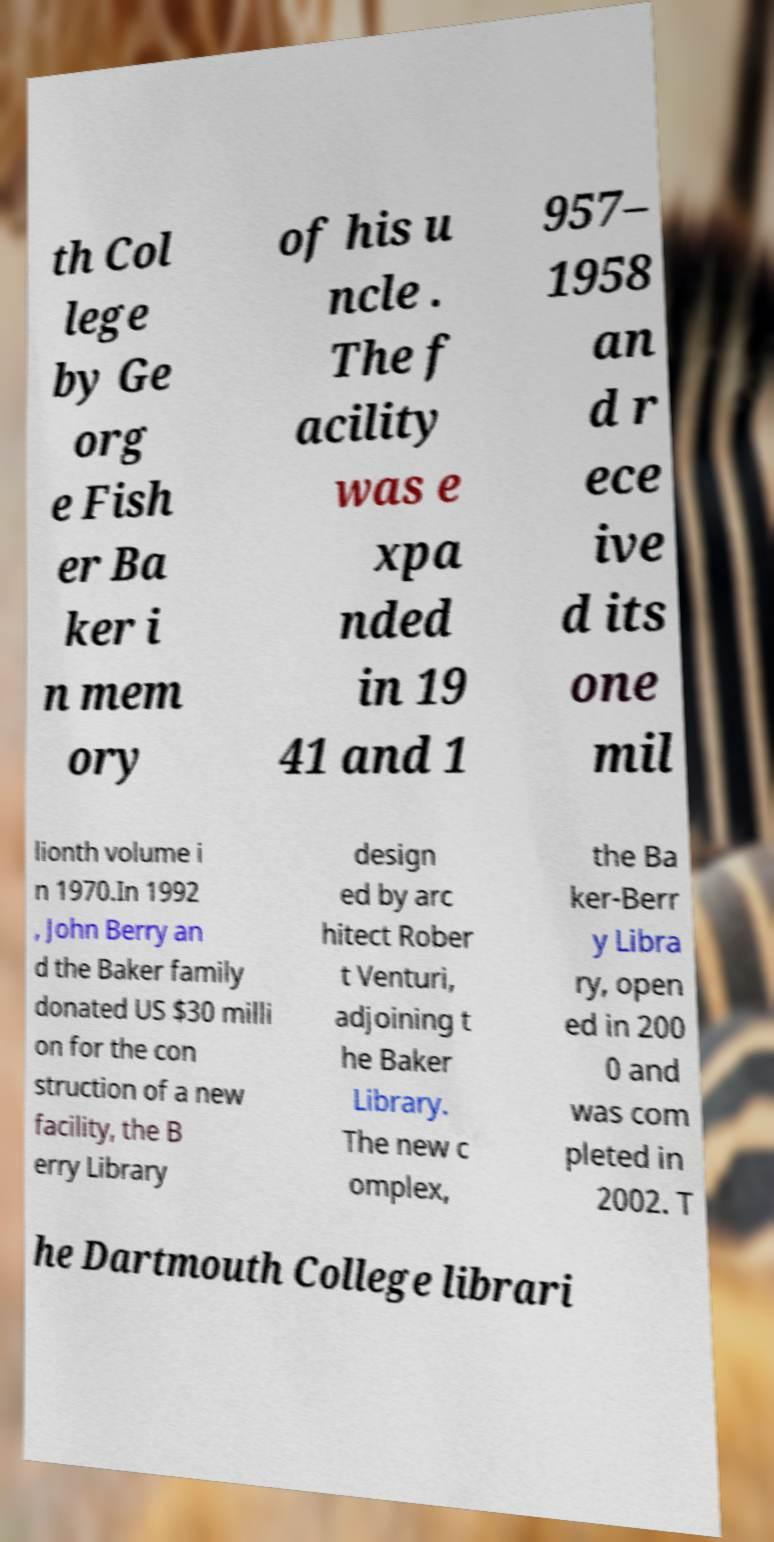Please identify and transcribe the text found in this image. th Col lege by Ge org e Fish er Ba ker i n mem ory of his u ncle . The f acility was e xpa nded in 19 41 and 1 957– 1958 an d r ece ive d its one mil lionth volume i n 1970.In 1992 , John Berry an d the Baker family donated US $30 milli on for the con struction of a new facility, the B erry Library design ed by arc hitect Rober t Venturi, adjoining t he Baker Library. The new c omplex, the Ba ker-Berr y Libra ry, open ed in 200 0 and was com pleted in 2002. T he Dartmouth College librari 